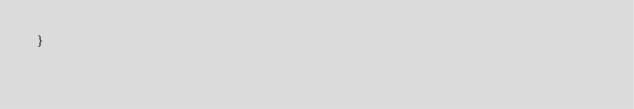Convert code to text. <code><loc_0><loc_0><loc_500><loc_500><_CSS_>}</code> 